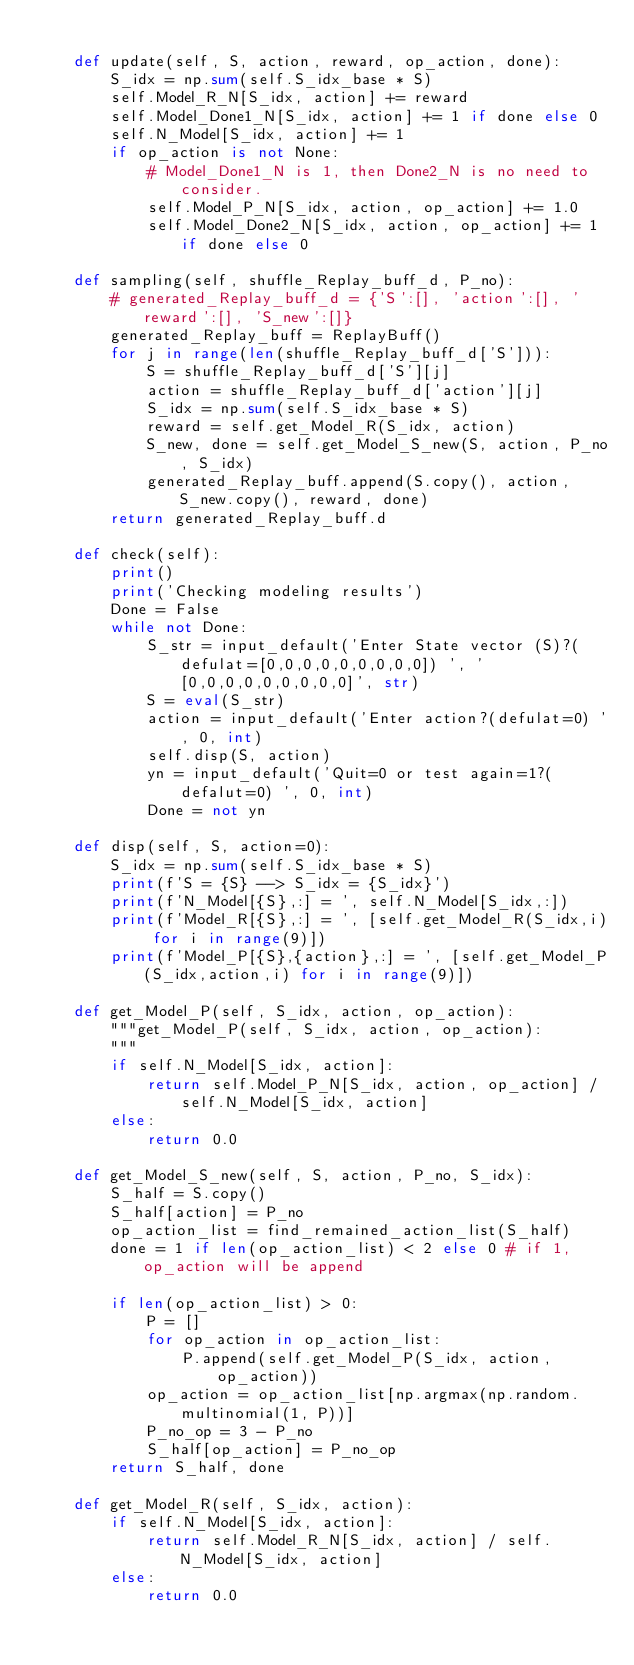<code> <loc_0><loc_0><loc_500><loc_500><_Python_>
    def update(self, S, action, reward, op_action, done):
        S_idx = np.sum(self.S_idx_base * S)
        self.Model_R_N[S_idx, action] += reward
        self.Model_Done1_N[S_idx, action] += 1 if done else 0
        self.N_Model[S_idx, action] += 1
        if op_action is not None:
            # Model_Done1_N is 1, then Done2_N is no need to consider. 
            self.Model_P_N[S_idx, action, op_action] += 1.0                    
            self.Model_Done2_N[S_idx, action, op_action] += 1 if done else 0

    def sampling(self, shuffle_Replay_buff_d, P_no):
        # generated_Replay_buff_d = {'S':[], 'action':[], 'reward':[], 'S_new':[]}
        generated_Replay_buff = ReplayBuff()
        for j in range(len(shuffle_Replay_buff_d['S'])):
            S = shuffle_Replay_buff_d['S'][j]
            action = shuffle_Replay_buff_d['action'][j]
            S_idx = np.sum(self.S_idx_base * S)
            reward = self.get_Model_R(S_idx, action)
            S_new, done = self.get_Model_S_new(S, action, P_no, S_idx)
            generated_Replay_buff.append(S.copy(), action, S_new.copy(), reward, done)
        return generated_Replay_buff.d

    def check(self):
        print()
        print('Checking modeling results')    
        Done = False
        while not Done:
            S_str = input_default('Enter State vector (S)?(defulat=[0,0,0,0,0,0,0,0,0]) ', '[0,0,0,0,0,0,0,0,0]', str)
            S = eval(S_str)
            action = input_default('Enter action?(defulat=0) ', 0, int)
            self.disp(S, action)
            yn = input_default('Quit=0 or test again=1?(defalut=0) ', 0, int)
            Done = not yn

    def disp(self, S, action=0):
        S_idx = np.sum(self.S_idx_base * S)
        print(f'S = {S} --> S_idx = {S_idx}')
        print(f'N_Model[{S},:] = ', self.N_Model[S_idx,:])
        print(f'Model_R[{S},:] = ', [self.get_Model_R(S_idx,i) for i in range(9)])
        print(f'Model_P[{S},{action},:] = ', [self.get_Model_P(S_idx,action,i) for i in range(9)])

    def get_Model_P(self, S_idx, action, op_action):
        """get_Model_P(self, S_idx, action, op_action):
        """
        if self.N_Model[S_idx, action]:
            return self.Model_P_N[S_idx, action, op_action] / self.N_Model[S_idx, action]
        else:
            return 0.0

    def get_Model_S_new(self, S, action, P_no, S_idx):
        S_half = S.copy()
        S_half[action] = P_no
        op_action_list = find_remained_action_list(S_half)
        done = 1 if len(op_action_list) < 2 else 0 # if 1, op_action will be append

        if len(op_action_list) > 0:
            P = []
            for op_action in op_action_list:
                P.append(self.get_Model_P(S_idx, action, op_action))
            op_action = op_action_list[np.argmax(np.random.multinomial(1, P))]
            P_no_op = 3 - P_no
            S_half[op_action] = P_no_op
        return S_half, done

    def get_Model_R(self, S_idx, action):
        if self.N_Model[S_idx, action]:
            return self.Model_R_N[S_idx, action] / self.N_Model[S_idx, action]
        else:
            return 0.0
</code> 